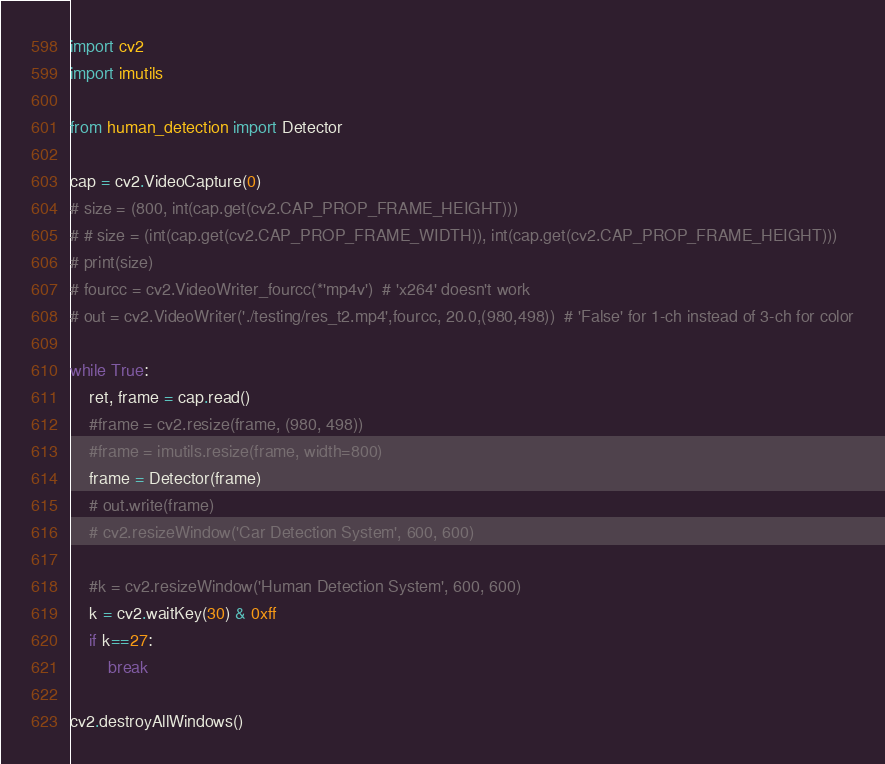Convert code to text. <code><loc_0><loc_0><loc_500><loc_500><_Python_>import cv2
import imutils

from human_detection import Detector

cap = cv2.VideoCapture(0)
# size = (800, int(cap.get(cv2.CAP_PROP_FRAME_HEIGHT)))
# # size = (int(cap.get(cv2.CAP_PROP_FRAME_WIDTH)), int(cap.get(cv2.CAP_PROP_FRAME_HEIGHT)))
# print(size)
# fourcc = cv2.VideoWriter_fourcc(*'mp4v')  # 'x264' doesn't work
# out = cv2.VideoWriter('./testing/res_t2.mp4',fourcc, 20.0,(980,498))  # 'False' for 1-ch instead of 3-ch for color

while True:
    ret, frame = cap.read()
    #frame = cv2.resize(frame, (980, 498))
    #frame = imutils.resize(frame, width=800)
    frame = Detector(frame)
    # out.write(frame)
    # cv2.resizeWindow('Car Detection System', 600, 600)

    #k = cv2.resizeWindow('Human Detection System', 600, 600)
    k = cv2.waitKey(30) & 0xff
    if k==27:
        break

cv2.destroyAllWindows()</code> 